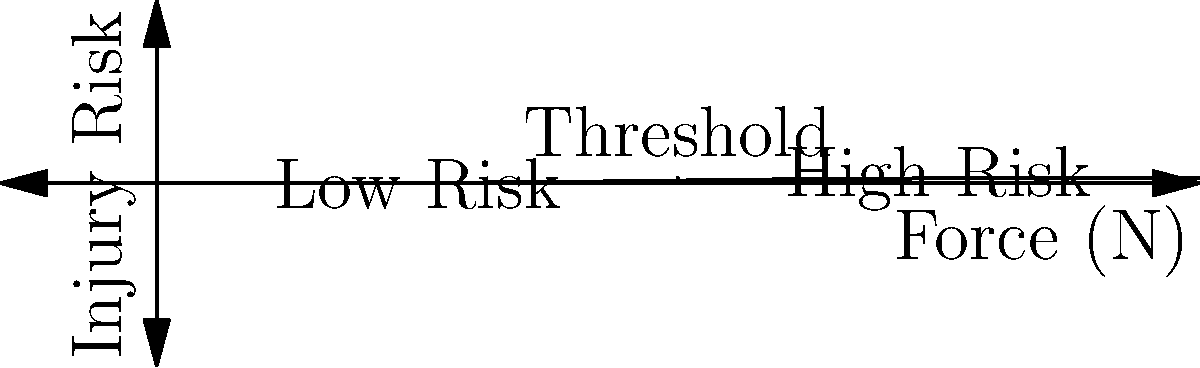Based on the graph showing the relationship between applied force and injury risk for medical equipment use, what ergonomic design principle should be prioritized to reduce workplace injuries among healthcare workers? To answer this question, we need to analyze the graph and understand its implications for ergonomic design:

1. The graph shows a sigmoidal relationship between applied force and injury risk.
2. There is a clear threshold around 100 N where the injury risk begins to increase rapidly.
3. Below this threshold, the injury risk remains relatively low.
4. Above this threshold, the injury risk increases sharply and approaches a high level.

Given this information, the key ergonomic design principle to prioritize is:

5. Minimize the force required to operate medical equipment, keeping it well below the 100 N threshold.
6. This can be achieved through various means such as:
   a) Using lightweight materials
   b) Implementing assistive mechanisms (e.g., hydraulics, pneumatics)
   c) Optimizing equipment layout and positioning

7. By keeping the required force low, we can maintain the injury risk in the "Low Risk" zone of the graph.

8. From a public health perspective, this approach would significantly reduce the incidence of workplace injuries among healthcare workers, leading to:
   a) Improved worker health and well-being
   b) Reduced absenteeism and healthcare costs
   c) Increased productivity and quality of care

Therefore, the primary ergonomic design principle to prioritize is force reduction in medical equipment operation.
Answer: Force reduction in equipment operation 